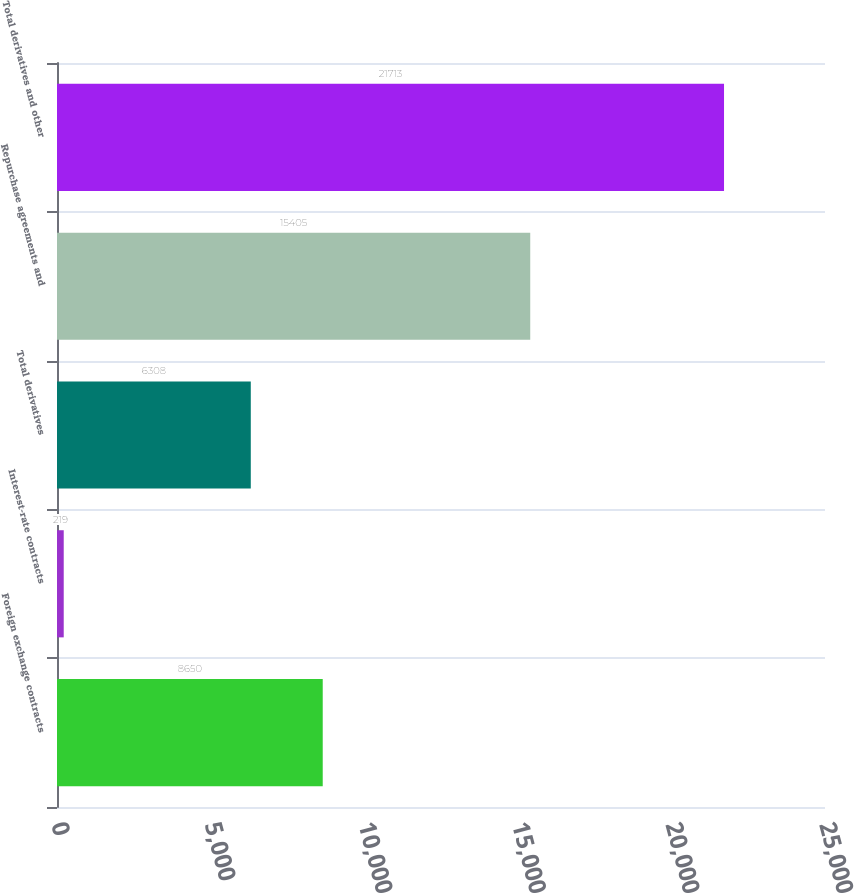<chart> <loc_0><loc_0><loc_500><loc_500><bar_chart><fcel>Foreign exchange contracts<fcel>Interest-rate contracts<fcel>Total derivatives<fcel>Repurchase agreements and<fcel>Total derivatives and other<nl><fcel>8650<fcel>219<fcel>6308<fcel>15405<fcel>21713<nl></chart> 